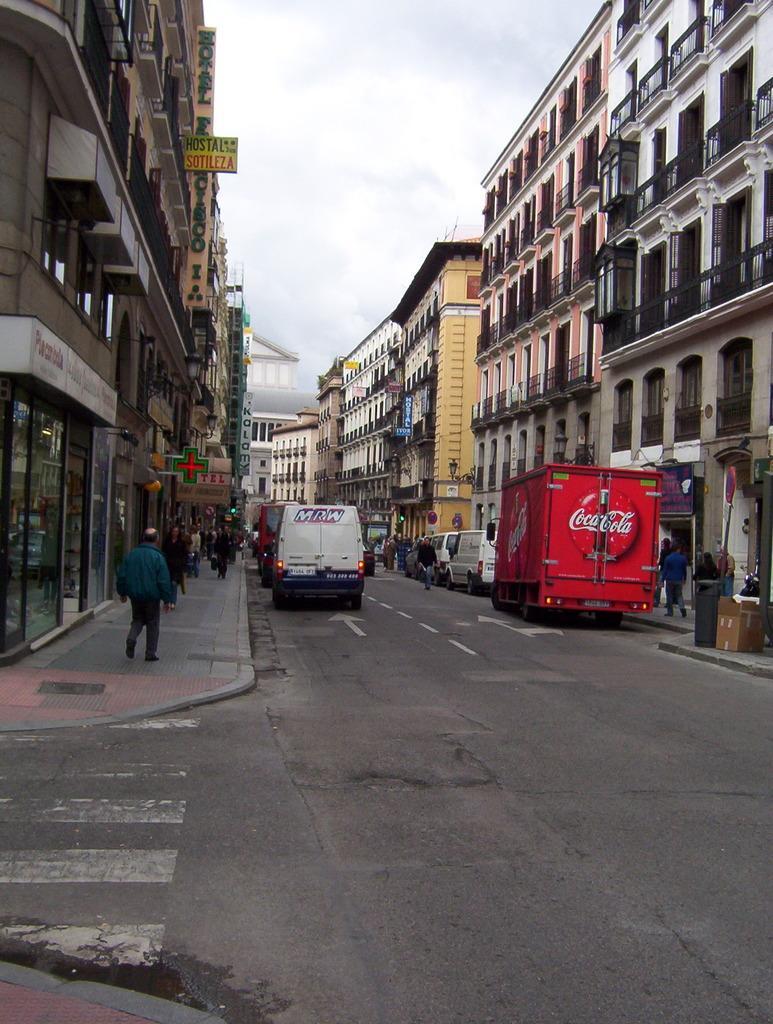Could you give a brief overview of what you see in this image? In this image, I can see the vehicles on the road. There are groups of people walking and buildings with the name boards. In the background, there is the sky. 